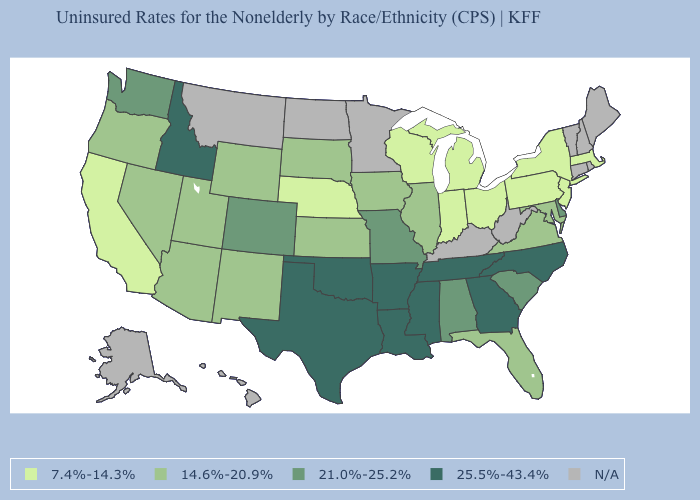What is the highest value in the Northeast ?
Concise answer only. 7.4%-14.3%. Is the legend a continuous bar?
Quick response, please. No. What is the value of Tennessee?
Write a very short answer. 25.5%-43.4%. How many symbols are there in the legend?
Answer briefly. 5. Name the states that have a value in the range 25.5%-43.4%?
Quick response, please. Arkansas, Georgia, Idaho, Louisiana, Mississippi, North Carolina, Oklahoma, Tennessee, Texas. What is the value of New Hampshire?
Quick response, please. N/A. Among the states that border Kentucky , which have the highest value?
Give a very brief answer. Tennessee. Name the states that have a value in the range 21.0%-25.2%?
Keep it brief. Alabama, Colorado, Delaware, Missouri, South Carolina, Washington. How many symbols are there in the legend?
Concise answer only. 5. What is the lowest value in the West?
Quick response, please. 7.4%-14.3%. Does the first symbol in the legend represent the smallest category?
Be succinct. Yes. Does Georgia have the highest value in the USA?
Give a very brief answer. Yes. What is the highest value in the West ?
Quick response, please. 25.5%-43.4%. What is the value of North Dakota?
Quick response, please. N/A. 